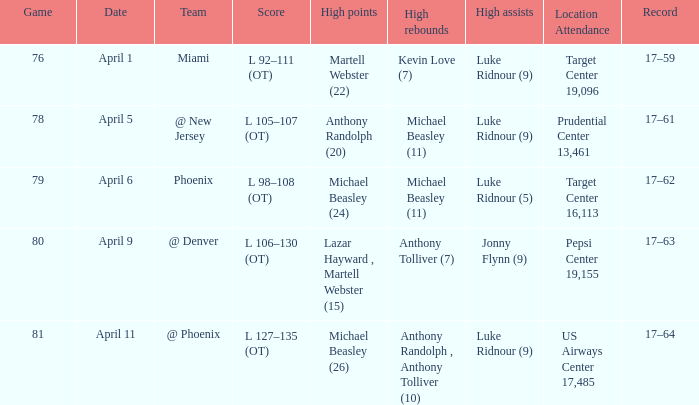What was the score in the game in which Michael Beasley (26) did the high points? L 127–135 (OT). 